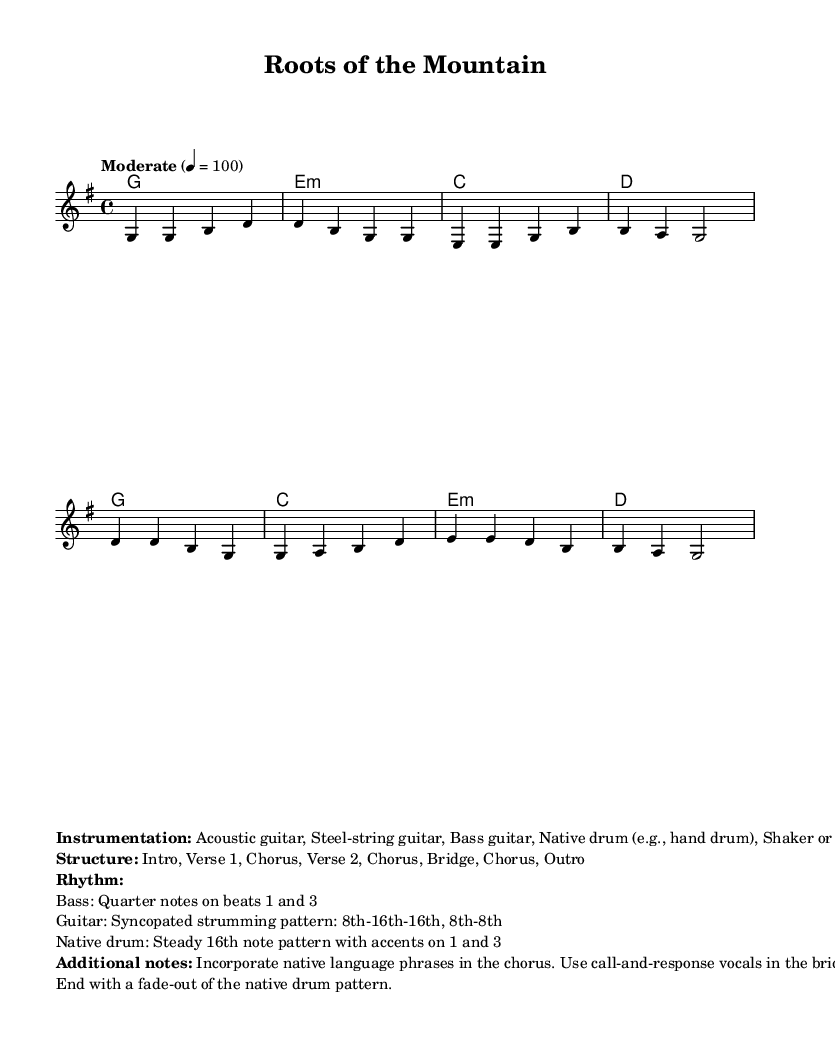What is the key signature of this music? The key signature is G major, which has one sharp (F#). This can be identified by looking at the signature at the beginning of the staff.
Answer: G major What is the time signature of this score? The time signature is 4/4, which is indicated at the beginning of the staff notation. This means there are four beats in each measure and the quarter note gets one beat.
Answer: 4/4 What is the tempo marking for this piece? The tempo marking is "Moderate" at 4 = 100, indicating a moderate speed for the music. This is typically found above the staff at the beginning of the sheet music.
Answer: Moderate How many verses are in the structure of the piece? The structure outlined states there are two verses (Verse 1 and Verse 2) before repeating the chorus. This can be determined by analyzing the structure section at the bottom of the sheet music.
Answer: Two What rhythmic pattern is used by the native drum? The native drum pattern consists of a steady 16th note rhythm with accents on beats 1 and 3. This specific detail is included in the additional notes section of the score.
Answer: Steady 16th note pattern What type of vocals are incorporated in the bridge? The bridge includes call-and-response vocals, as stated in the additional notes. This means one vocalist will sing a line, followed by another vocalist responding.
Answer: Call-and-response What instruments are used in the arrangement? The instrumentation includes acoustic guitar, steel-string guitar, bass guitar, native drum, and shaker or rattle. This list is clearly specified in the notation under the instrumentation section.
Answer: Acoustic guitar, Steel-string guitar, Bass guitar, Native drum, Shaker 